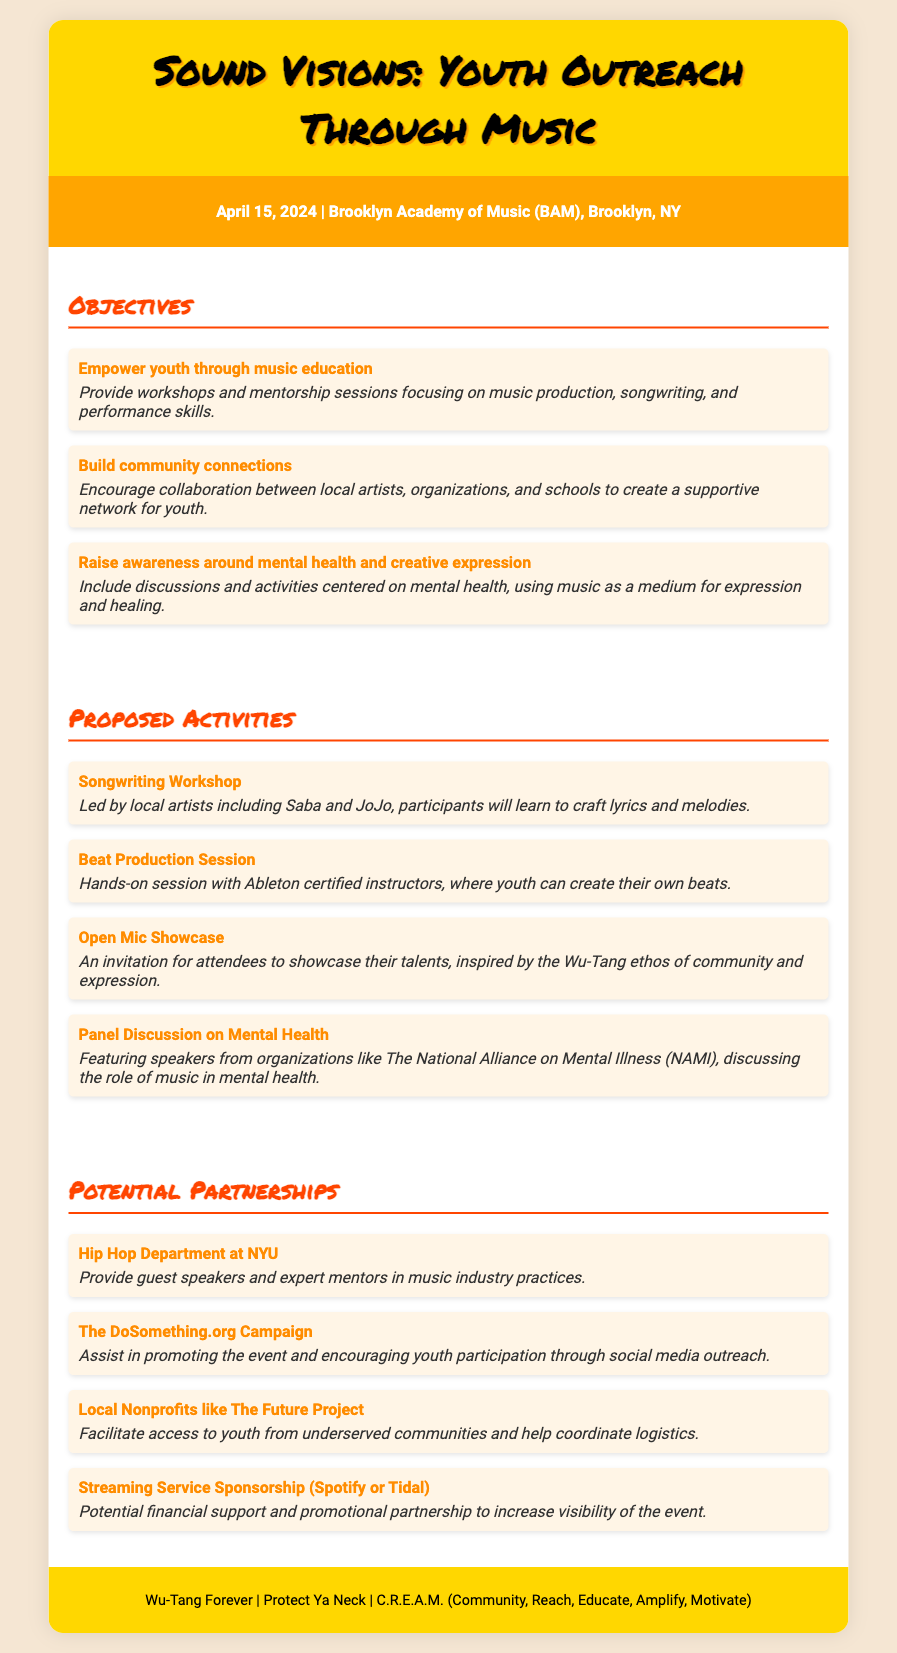What is the title of the event? The title is presented at the top of the document in a prominent header.
Answer: Sound Visions: Youth Outreach Through Music What date is the event scheduled for? The date is listed in the event details section of the document.
Answer: April 15, 2024 Where is the event taking place? The location is noted right after the date in the event details.
Answer: Brooklyn Academy of Music (BAM), Brooklyn, NY Who are some local artists leading workshops? The names of specific artists are mentioned in the proposed activities section.
Answer: Saba and JoJo What is one objective of the event? The objectives are outlined in a list format within the document.
Answer: Empower youth through music education How many proposed activities are listed? The total count can be found by reviewing the proposed activities section.
Answer: Four Which organization will assist in promoting the event? The potential partnerships section identifies organizations involved.
Answer: The DoSomething.org Campaign What is one role of the Hip Hop Department at NYU? Their specific contribution is mentioned in the context of partnerships in the document.
Answer: Provide guest speakers and expert mentors What type of session will have hands-on experience with software? The proposed activities section specifies the nature of this session.
Answer: Beat Production Session What is the overarching theme of the panel discussion? The theme can be inferred from the title of the activity listed in proposed activities.
Answer: Mental Health 